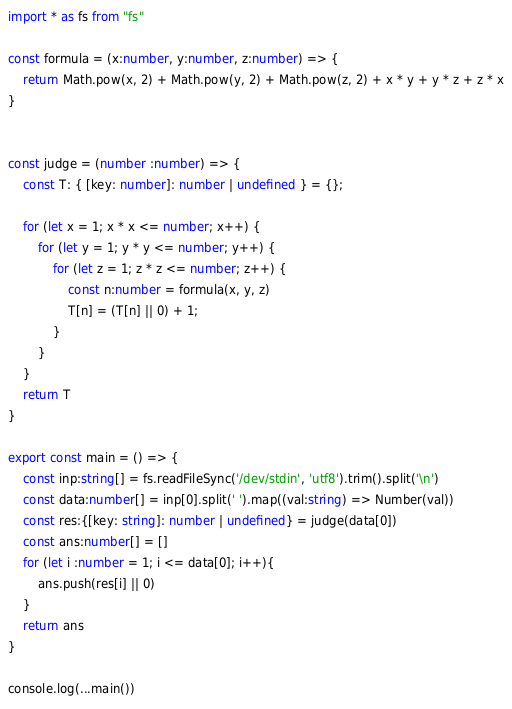<code> <loc_0><loc_0><loc_500><loc_500><_TypeScript_>import * as fs from "fs"

const formula = (x:number, y:number, z:number) => {
    return Math.pow(x, 2) + Math.pow(y, 2) + Math.pow(z, 2) + x * y + y * z + z * x
}


const judge = (number :number) => {
    const T: { [key: number]: number | undefined } = {};

    for (let x = 1; x * x <= number; x++) {
        for (let y = 1; y * y <= number; y++) {
            for (let z = 1; z * z <= number; z++) {
                const n:number = formula(x, y, z)
                T[n] = (T[n] || 0) + 1;
            }
        }
    }
    return T
}

export const main = () => {
    const inp:string[] = fs.readFileSync('/dev/stdin', 'utf8').trim().split('\n')
    const data:number[] = inp[0].split(' ').map((val:string) => Number(val))
    const res:{[key: string]: number | undefined} = judge(data[0])
    const ans:number[] = []
    for (let i :number = 1; i <= data[0]; i++){
        ans.push(res[i] || 0)
    }
    return ans
}

console.log(...main())
</code> 